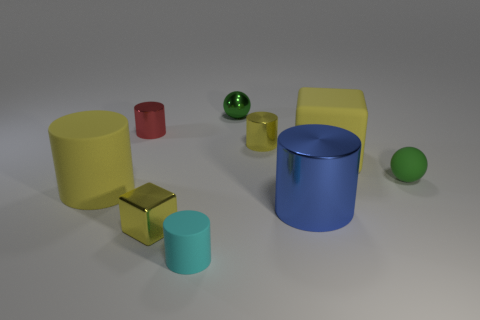Is there a small yellow block right of the large cylinder to the right of the small yellow metallic cylinder?
Ensure brevity in your answer.  No. There is a rubber cylinder that is the same color as the tiny cube; what is its size?
Your answer should be very brief. Large. What is the shape of the small object to the right of the blue thing?
Ensure brevity in your answer.  Sphere. There is a yellow thing in front of the metallic thing to the right of the tiny yellow metallic cylinder; how many green metal spheres are in front of it?
Offer a very short reply. 0. Is the size of the shiny ball the same as the rubber cylinder in front of the big blue cylinder?
Make the answer very short. Yes. There is a shiny ball that is behind the small shiny cylinder to the left of the small yellow block; how big is it?
Provide a succinct answer. Small. What number of red things have the same material as the cyan cylinder?
Your response must be concise. 0. Is there a red matte sphere?
Make the answer very short. No. What is the size of the rubber thing to the left of the small cyan matte thing?
Keep it short and to the point. Large. How many small metallic blocks are the same color as the large block?
Your answer should be compact. 1. 